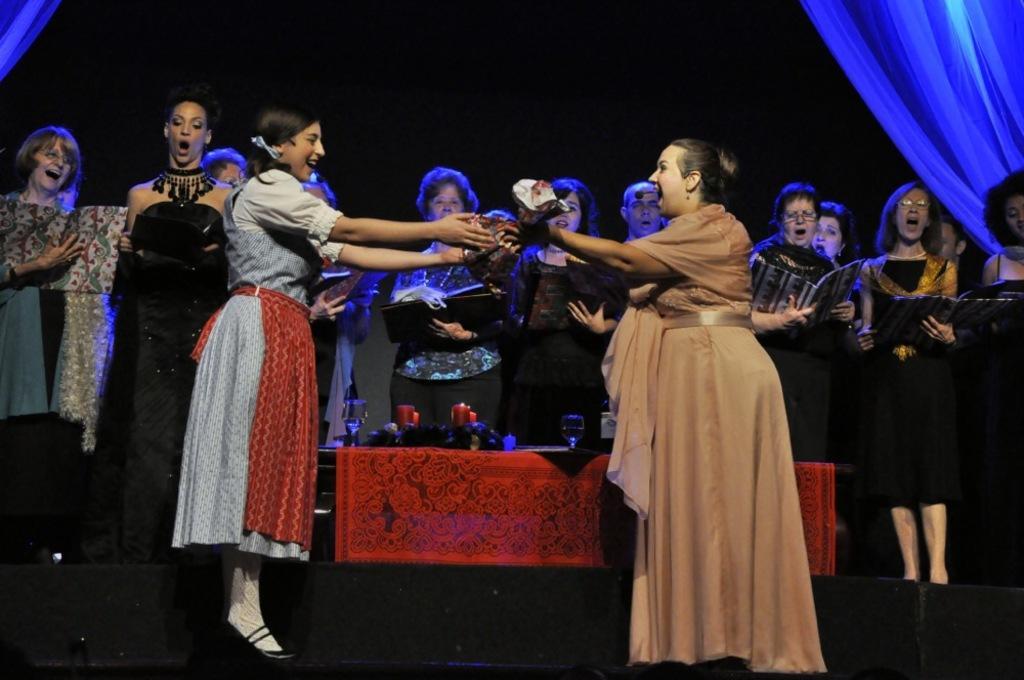In one or two sentences, can you explain what this image depicts? In this image in front there are two people holding some object. Behind them there are a few other people holding the books. In the center of the image there is a table. On top of it there are glasses, candles and a few other objects. In the background of the image there are curtains. 